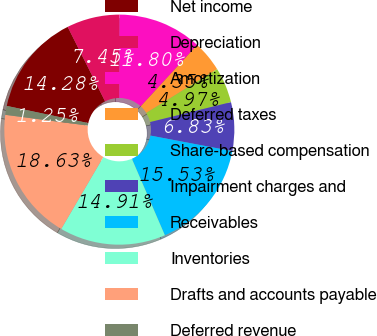<chart> <loc_0><loc_0><loc_500><loc_500><pie_chart><fcel>Net income<fcel>Depreciation<fcel>Amortization<fcel>Deferred taxes<fcel>Share-based compensation<fcel>Impairment charges and<fcel>Receivables<fcel>Inventories<fcel>Drafts and accounts payable<fcel>Deferred revenue<nl><fcel>14.28%<fcel>7.45%<fcel>11.8%<fcel>4.35%<fcel>4.97%<fcel>6.83%<fcel>15.53%<fcel>14.91%<fcel>18.63%<fcel>1.25%<nl></chart> 